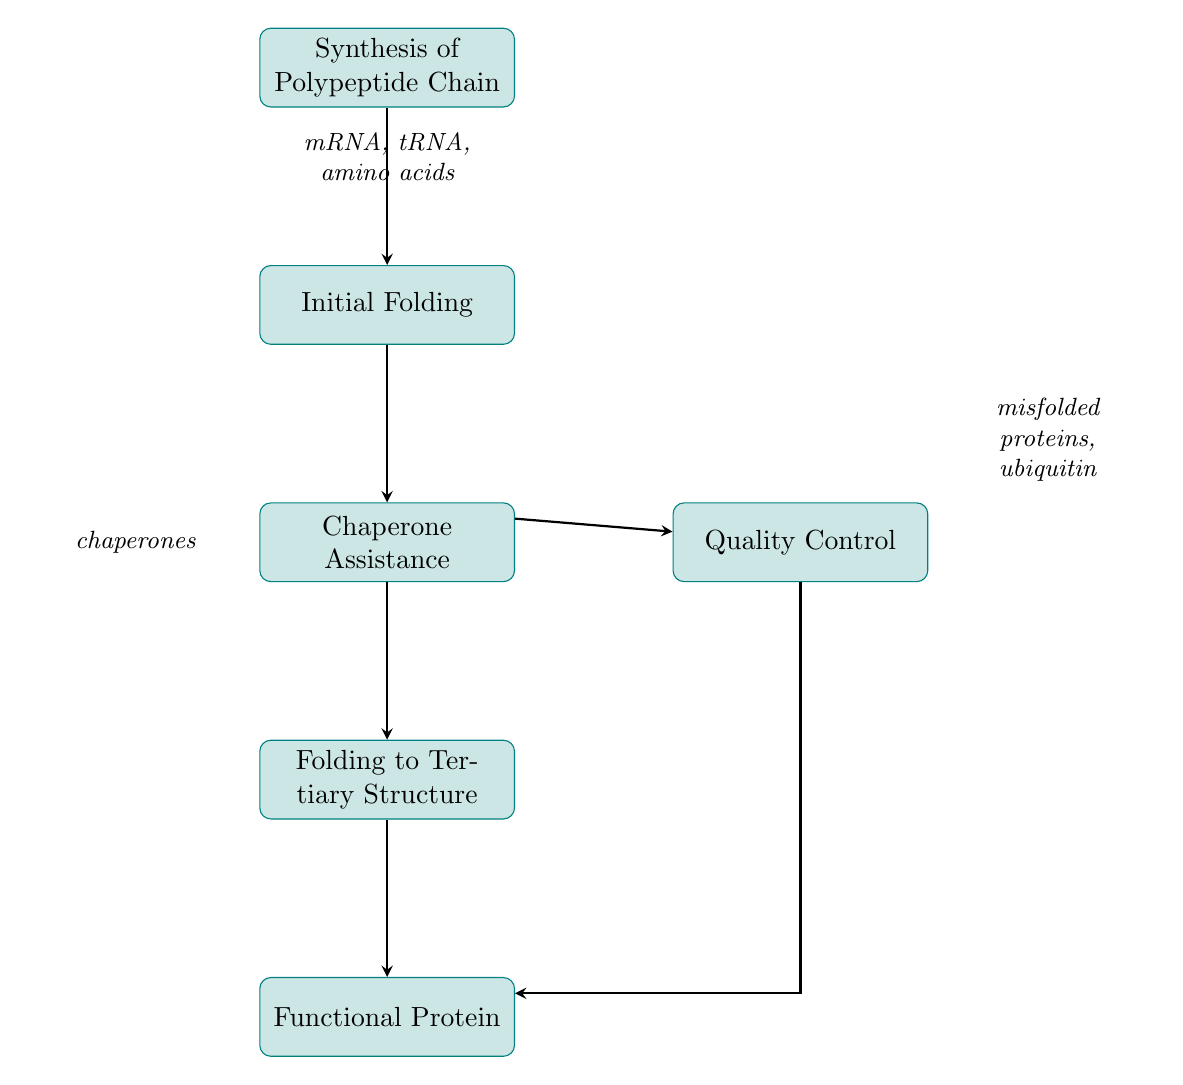What is the first step in the protein folding process? The diagram shows "Synthesis of Polypeptide Chain" as the first node, indicating it as the initial action in the process.
Answer: Synthesis of Polypeptide Chain How many main steps are there in the protein folding process? Counting the nodes in the diagram, there are six primary steps represented, including synthesis, folding, chaperone assistance, quality control, and functional protein.
Answer: Six What is the primary function of molecular chaperones in this process? The description of "Chaperone Assistance" states that molecular chaperones help in correct folding and prevent protein aggregation, highlighting their essential role in maintaining protein integrity.
Answer: Correct folding What inputs are involved in the initial folding stage? The "Initial Folding" step directly references the "polypeptide chain" as its sole input, which is crucial for beginning the folding process after synthesis.
Answer: Polypeptide chain What happens if proteins are misfolded according to the diagram? The "Quality Control" node describes that misfolded proteins are targeted for degradation by the proteasome, indicating a mechanism for dealing with improperly folded proteins.
Answer: Targeted for degradation How does the flow of the process proceed from chaperone assistance? The flow arrows indicate that after "Chaperone Assistance," the next step in the process is "Folding to Tertiary Structure," showing a sequential progression.
Answer: Folding to Tertiary Structure What is produced after the "Folding to Tertiary Structure" process? Following the "Folding to Tertiary Structure" step, the output is labeled as "fully folded protein," indicating the result of this specific stage in the process.
Answer: Fully folded protein Which step leads to the formation of functional proteins? The final step "Functional Protein" is reached after "Folding to Tertiary Structure," confirming that this is where the correctly folded proteins become biologically active.
Answer: Functional Protein 